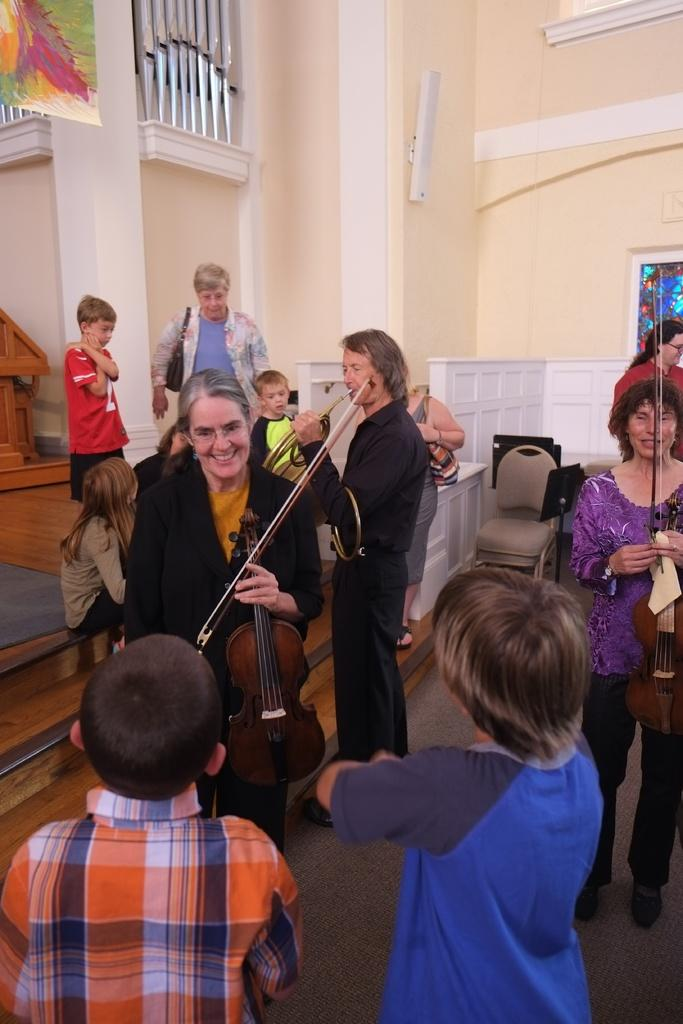What is the main setting of the image? There is a room in the image. What are the people in the room doing? Many people are standing in the room, holding and playing musical items. Are there any children present in the room? Yes, there are small children in the room. What type of care can be seen being provided to the zipper in the image? There is no zipper present in the image, so no care is being provided to it. What sense is being stimulated by the musical items in the image? The image does not specify which sense is being stimulated by the musical items; however, it is likely that the sense of hearing is being stimulated as the people are playing musical items. 